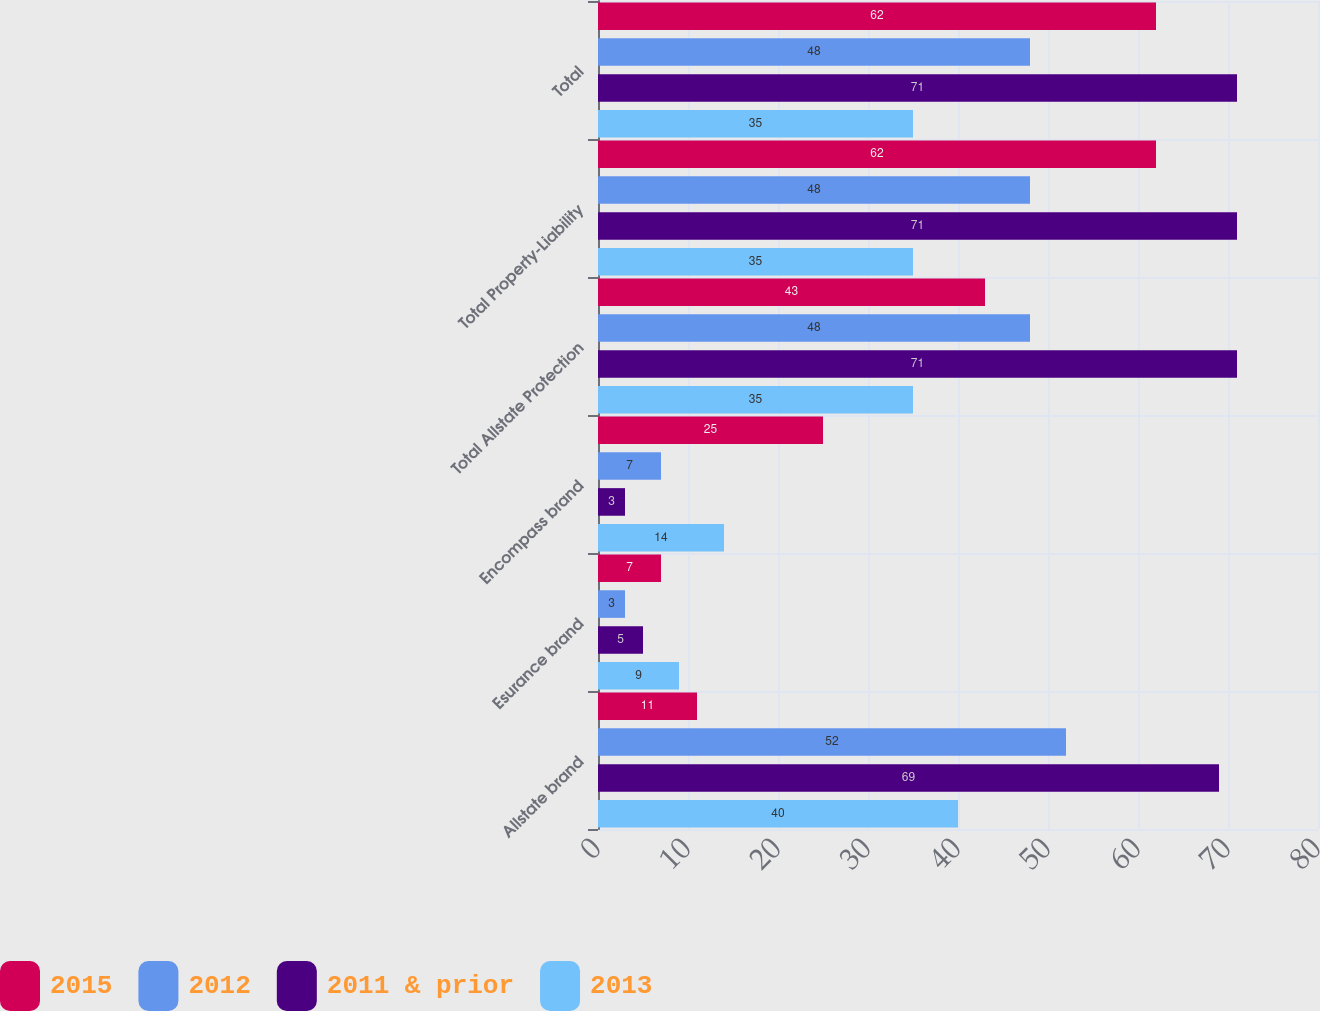Convert chart. <chart><loc_0><loc_0><loc_500><loc_500><stacked_bar_chart><ecel><fcel>Allstate brand<fcel>Esurance brand<fcel>Encompass brand<fcel>Total Allstate Protection<fcel>Total Property-Liability<fcel>Total<nl><fcel>2015<fcel>11<fcel>7<fcel>25<fcel>43<fcel>62<fcel>62<nl><fcel>2012<fcel>52<fcel>3<fcel>7<fcel>48<fcel>48<fcel>48<nl><fcel>2011 & prior<fcel>69<fcel>5<fcel>3<fcel>71<fcel>71<fcel>71<nl><fcel>2013<fcel>40<fcel>9<fcel>14<fcel>35<fcel>35<fcel>35<nl></chart> 